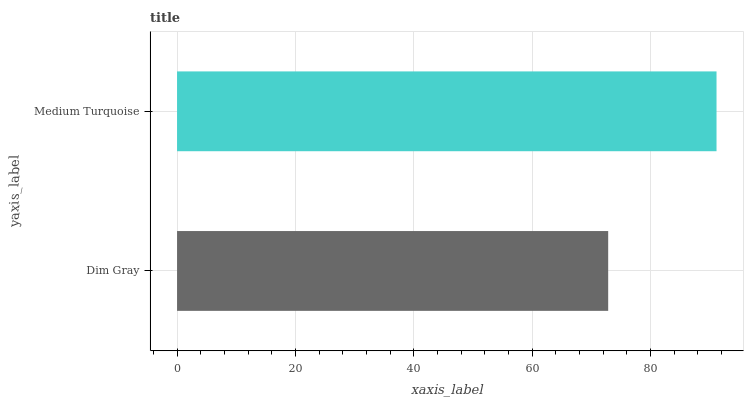Is Dim Gray the minimum?
Answer yes or no. Yes. Is Medium Turquoise the maximum?
Answer yes or no. Yes. Is Medium Turquoise the minimum?
Answer yes or no. No. Is Medium Turquoise greater than Dim Gray?
Answer yes or no. Yes. Is Dim Gray less than Medium Turquoise?
Answer yes or no. Yes. Is Dim Gray greater than Medium Turquoise?
Answer yes or no. No. Is Medium Turquoise less than Dim Gray?
Answer yes or no. No. Is Medium Turquoise the high median?
Answer yes or no. Yes. Is Dim Gray the low median?
Answer yes or no. Yes. Is Dim Gray the high median?
Answer yes or no. No. Is Medium Turquoise the low median?
Answer yes or no. No. 